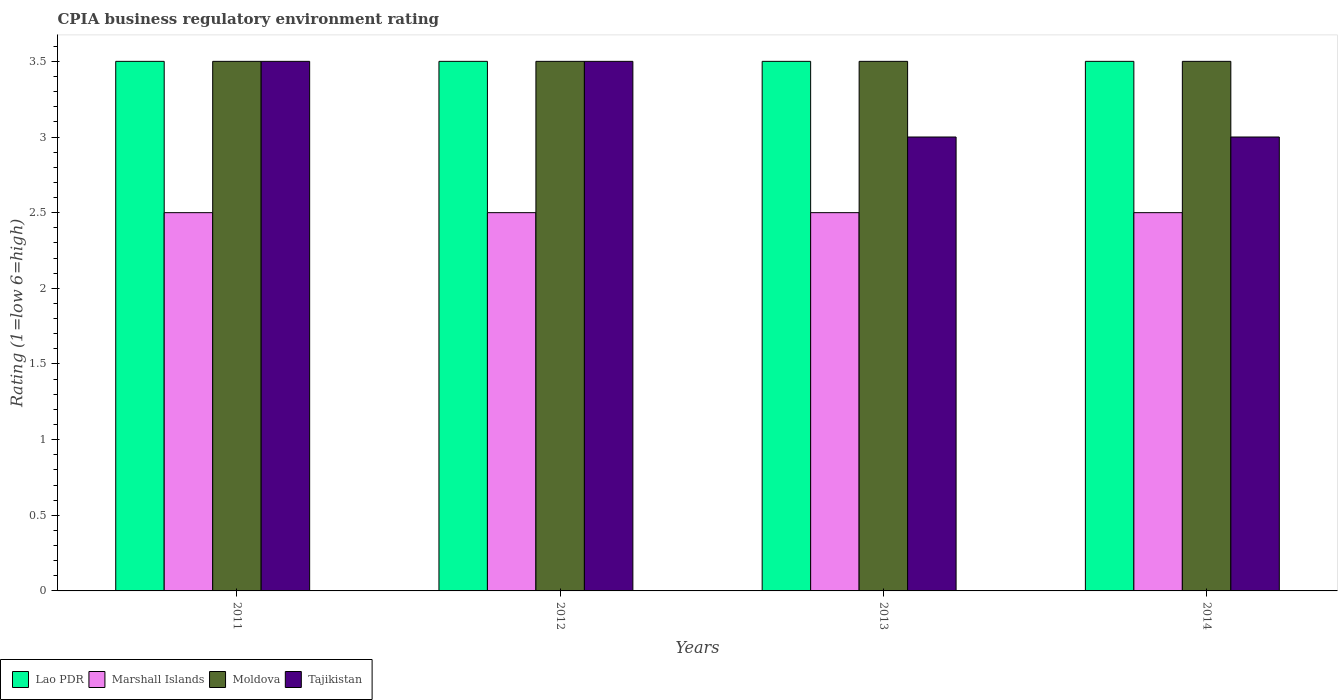How many groups of bars are there?
Provide a short and direct response. 4. How many bars are there on the 3rd tick from the left?
Make the answer very short. 4. How many bars are there on the 1st tick from the right?
Your response must be concise. 4. Across all years, what is the maximum CPIA rating in Lao PDR?
Make the answer very short. 3.5. In which year was the CPIA rating in Marshall Islands maximum?
Offer a terse response. 2011. In which year was the CPIA rating in Tajikistan minimum?
Give a very brief answer. 2013. What is the difference between the CPIA rating in Marshall Islands in 2013 and that in 2014?
Your answer should be very brief. 0. What is the difference between the CPIA rating in Moldova in 2012 and the CPIA rating in Marshall Islands in 2013?
Make the answer very short. 1. In how many years, is the CPIA rating in Lao PDR greater than 0.8?
Ensure brevity in your answer.  4. Is the CPIA rating in Lao PDR in 2013 less than that in 2014?
Ensure brevity in your answer.  No. What is the difference between the highest and the second highest CPIA rating in Tajikistan?
Make the answer very short. 0. What is the difference between the highest and the lowest CPIA rating in Marshall Islands?
Provide a short and direct response. 0. In how many years, is the CPIA rating in Tajikistan greater than the average CPIA rating in Tajikistan taken over all years?
Offer a terse response. 2. Is the sum of the CPIA rating in Moldova in 2011 and 2014 greater than the maximum CPIA rating in Tajikistan across all years?
Offer a very short reply. Yes. What does the 3rd bar from the left in 2011 represents?
Your response must be concise. Moldova. What does the 3rd bar from the right in 2011 represents?
Provide a succinct answer. Marshall Islands. How many bars are there?
Provide a succinct answer. 16. How many years are there in the graph?
Provide a short and direct response. 4. Does the graph contain any zero values?
Keep it short and to the point. No. Does the graph contain grids?
Ensure brevity in your answer.  No. How are the legend labels stacked?
Make the answer very short. Horizontal. What is the title of the graph?
Your answer should be compact. CPIA business regulatory environment rating. What is the label or title of the X-axis?
Give a very brief answer. Years. What is the label or title of the Y-axis?
Make the answer very short. Rating (1=low 6=high). What is the Rating (1=low 6=high) in Lao PDR in 2011?
Your answer should be very brief. 3.5. What is the Rating (1=low 6=high) in Marshall Islands in 2011?
Your answer should be compact. 2.5. What is the Rating (1=low 6=high) in Moldova in 2011?
Give a very brief answer. 3.5. What is the Rating (1=low 6=high) in Tajikistan in 2011?
Your answer should be very brief. 3.5. What is the Rating (1=low 6=high) of Marshall Islands in 2012?
Provide a succinct answer. 2.5. What is the Rating (1=low 6=high) of Moldova in 2012?
Make the answer very short. 3.5. What is the Rating (1=low 6=high) of Marshall Islands in 2013?
Give a very brief answer. 2.5. What is the Rating (1=low 6=high) of Moldova in 2013?
Your response must be concise. 3.5. What is the Rating (1=low 6=high) in Tajikistan in 2013?
Make the answer very short. 3. What is the Rating (1=low 6=high) of Lao PDR in 2014?
Your answer should be compact. 3.5. What is the Rating (1=low 6=high) of Moldova in 2014?
Keep it short and to the point. 3.5. Across all years, what is the maximum Rating (1=low 6=high) in Lao PDR?
Offer a very short reply. 3.5. Across all years, what is the maximum Rating (1=low 6=high) of Marshall Islands?
Provide a short and direct response. 2.5. Across all years, what is the maximum Rating (1=low 6=high) in Moldova?
Give a very brief answer. 3.5. Across all years, what is the maximum Rating (1=low 6=high) in Tajikistan?
Offer a very short reply. 3.5. Across all years, what is the minimum Rating (1=low 6=high) in Marshall Islands?
Your answer should be compact. 2.5. What is the total Rating (1=low 6=high) of Marshall Islands in the graph?
Provide a short and direct response. 10. What is the total Rating (1=low 6=high) of Moldova in the graph?
Provide a succinct answer. 14. What is the difference between the Rating (1=low 6=high) in Lao PDR in 2011 and that in 2014?
Ensure brevity in your answer.  0. What is the difference between the Rating (1=low 6=high) in Tajikistan in 2011 and that in 2014?
Provide a short and direct response. 0.5. What is the difference between the Rating (1=low 6=high) in Moldova in 2012 and that in 2013?
Your answer should be very brief. 0. What is the difference between the Rating (1=low 6=high) of Tajikistan in 2012 and that in 2013?
Offer a terse response. 0.5. What is the difference between the Rating (1=low 6=high) of Moldova in 2012 and that in 2014?
Give a very brief answer. 0. What is the difference between the Rating (1=low 6=high) in Tajikistan in 2012 and that in 2014?
Offer a very short reply. 0.5. What is the difference between the Rating (1=low 6=high) in Lao PDR in 2013 and that in 2014?
Provide a short and direct response. 0. What is the difference between the Rating (1=low 6=high) of Lao PDR in 2011 and the Rating (1=low 6=high) of Moldova in 2012?
Offer a very short reply. 0. What is the difference between the Rating (1=low 6=high) of Moldova in 2011 and the Rating (1=low 6=high) of Tajikistan in 2012?
Offer a very short reply. 0. What is the difference between the Rating (1=low 6=high) in Marshall Islands in 2011 and the Rating (1=low 6=high) in Moldova in 2013?
Keep it short and to the point. -1. What is the difference between the Rating (1=low 6=high) in Marshall Islands in 2011 and the Rating (1=low 6=high) in Tajikistan in 2013?
Keep it short and to the point. -0.5. What is the difference between the Rating (1=low 6=high) of Moldova in 2011 and the Rating (1=low 6=high) of Tajikistan in 2013?
Ensure brevity in your answer.  0.5. What is the difference between the Rating (1=low 6=high) in Lao PDR in 2011 and the Rating (1=low 6=high) in Marshall Islands in 2014?
Make the answer very short. 1. What is the difference between the Rating (1=low 6=high) in Moldova in 2011 and the Rating (1=low 6=high) in Tajikistan in 2014?
Make the answer very short. 0.5. What is the difference between the Rating (1=low 6=high) in Lao PDR in 2012 and the Rating (1=low 6=high) in Marshall Islands in 2013?
Ensure brevity in your answer.  1. What is the difference between the Rating (1=low 6=high) in Lao PDR in 2012 and the Rating (1=low 6=high) in Tajikistan in 2013?
Offer a terse response. 0.5. What is the difference between the Rating (1=low 6=high) in Moldova in 2012 and the Rating (1=low 6=high) in Tajikistan in 2013?
Offer a very short reply. 0.5. What is the difference between the Rating (1=low 6=high) of Lao PDR in 2012 and the Rating (1=low 6=high) of Moldova in 2014?
Offer a terse response. 0. What is the difference between the Rating (1=low 6=high) in Marshall Islands in 2012 and the Rating (1=low 6=high) in Moldova in 2014?
Your answer should be compact. -1. What is the difference between the Rating (1=low 6=high) in Lao PDR in 2013 and the Rating (1=low 6=high) in Marshall Islands in 2014?
Your answer should be very brief. 1. What is the difference between the Rating (1=low 6=high) of Lao PDR in 2013 and the Rating (1=low 6=high) of Moldova in 2014?
Ensure brevity in your answer.  0. What is the difference between the Rating (1=low 6=high) of Marshall Islands in 2013 and the Rating (1=low 6=high) of Moldova in 2014?
Ensure brevity in your answer.  -1. What is the difference between the Rating (1=low 6=high) in Moldova in 2013 and the Rating (1=low 6=high) in Tajikistan in 2014?
Make the answer very short. 0.5. What is the average Rating (1=low 6=high) of Marshall Islands per year?
Your answer should be very brief. 2.5. In the year 2011, what is the difference between the Rating (1=low 6=high) of Lao PDR and Rating (1=low 6=high) of Moldova?
Make the answer very short. 0. In the year 2011, what is the difference between the Rating (1=low 6=high) of Lao PDR and Rating (1=low 6=high) of Tajikistan?
Provide a short and direct response. 0. In the year 2011, what is the difference between the Rating (1=low 6=high) of Marshall Islands and Rating (1=low 6=high) of Moldova?
Provide a succinct answer. -1. In the year 2012, what is the difference between the Rating (1=low 6=high) of Lao PDR and Rating (1=low 6=high) of Moldova?
Offer a terse response. 0. In the year 2012, what is the difference between the Rating (1=low 6=high) of Lao PDR and Rating (1=low 6=high) of Tajikistan?
Ensure brevity in your answer.  0. In the year 2012, what is the difference between the Rating (1=low 6=high) of Marshall Islands and Rating (1=low 6=high) of Moldova?
Your answer should be compact. -1. In the year 2012, what is the difference between the Rating (1=low 6=high) of Moldova and Rating (1=low 6=high) of Tajikistan?
Offer a very short reply. 0. In the year 2013, what is the difference between the Rating (1=low 6=high) in Lao PDR and Rating (1=low 6=high) in Moldova?
Provide a succinct answer. 0. In the year 2013, what is the difference between the Rating (1=low 6=high) in Marshall Islands and Rating (1=low 6=high) in Moldova?
Provide a short and direct response. -1. In the year 2013, what is the difference between the Rating (1=low 6=high) of Moldova and Rating (1=low 6=high) of Tajikistan?
Your response must be concise. 0.5. In the year 2014, what is the difference between the Rating (1=low 6=high) in Lao PDR and Rating (1=low 6=high) in Marshall Islands?
Your answer should be very brief. 1. In the year 2014, what is the difference between the Rating (1=low 6=high) of Lao PDR and Rating (1=low 6=high) of Moldova?
Your answer should be very brief. 0. In the year 2014, what is the difference between the Rating (1=low 6=high) of Marshall Islands and Rating (1=low 6=high) of Moldova?
Provide a succinct answer. -1. In the year 2014, what is the difference between the Rating (1=low 6=high) in Marshall Islands and Rating (1=low 6=high) in Tajikistan?
Your answer should be compact. -0.5. In the year 2014, what is the difference between the Rating (1=low 6=high) in Moldova and Rating (1=low 6=high) in Tajikistan?
Offer a terse response. 0.5. What is the ratio of the Rating (1=low 6=high) in Lao PDR in 2011 to that in 2012?
Offer a very short reply. 1. What is the ratio of the Rating (1=low 6=high) of Marshall Islands in 2011 to that in 2012?
Offer a terse response. 1. What is the ratio of the Rating (1=low 6=high) of Moldova in 2011 to that in 2012?
Your answer should be compact. 1. What is the ratio of the Rating (1=low 6=high) in Tajikistan in 2011 to that in 2012?
Provide a succinct answer. 1. What is the ratio of the Rating (1=low 6=high) in Lao PDR in 2011 to that in 2013?
Offer a very short reply. 1. What is the ratio of the Rating (1=low 6=high) of Marshall Islands in 2011 to that in 2013?
Ensure brevity in your answer.  1. What is the ratio of the Rating (1=low 6=high) of Moldova in 2011 to that in 2013?
Keep it short and to the point. 1. What is the ratio of the Rating (1=low 6=high) of Tajikistan in 2011 to that in 2013?
Provide a succinct answer. 1.17. What is the ratio of the Rating (1=low 6=high) of Marshall Islands in 2011 to that in 2014?
Provide a succinct answer. 1. What is the ratio of the Rating (1=low 6=high) in Lao PDR in 2012 to that in 2013?
Offer a terse response. 1. What is the ratio of the Rating (1=low 6=high) in Moldova in 2012 to that in 2013?
Give a very brief answer. 1. What is the ratio of the Rating (1=low 6=high) in Lao PDR in 2013 to that in 2014?
Offer a terse response. 1. What is the ratio of the Rating (1=low 6=high) of Marshall Islands in 2013 to that in 2014?
Offer a terse response. 1. What is the ratio of the Rating (1=low 6=high) in Moldova in 2013 to that in 2014?
Offer a very short reply. 1. What is the difference between the highest and the second highest Rating (1=low 6=high) in Lao PDR?
Keep it short and to the point. 0. What is the difference between the highest and the second highest Rating (1=low 6=high) in Marshall Islands?
Provide a short and direct response. 0. What is the difference between the highest and the second highest Rating (1=low 6=high) of Moldova?
Your answer should be very brief. 0. What is the difference between the highest and the lowest Rating (1=low 6=high) of Tajikistan?
Offer a terse response. 0.5. 